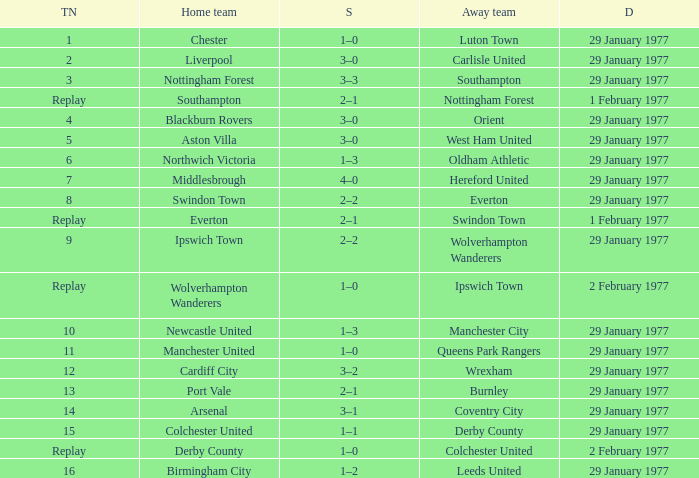What is the score in the Liverpool home game? 3–0. 